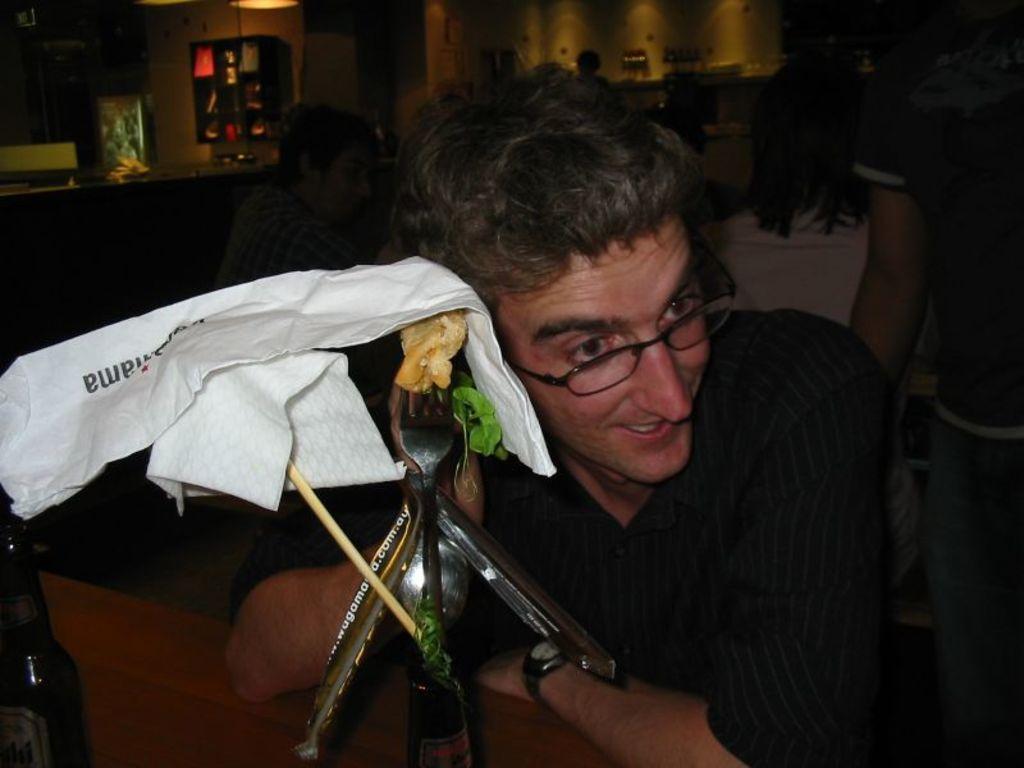Can you describe this image briefly? In this image we can see a person near a table containing a bottle with group of spoons, some tissue papers and a fork with some food placed on it. On the backside we can see some people, a wall, cupboard and a lamp. 